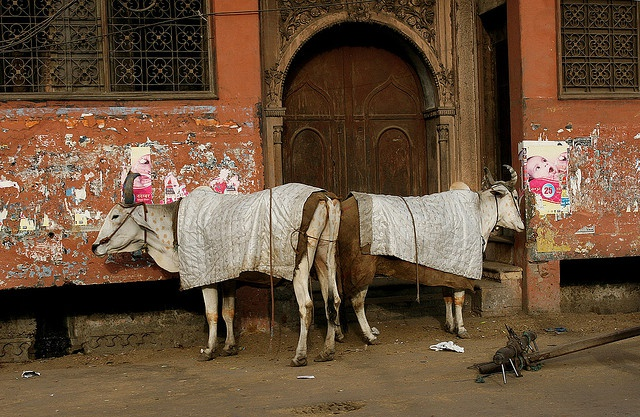Describe the objects in this image and their specific colors. I can see cow in black, darkgray, and tan tones and cow in black, darkgray, maroon, and lightgray tones in this image. 